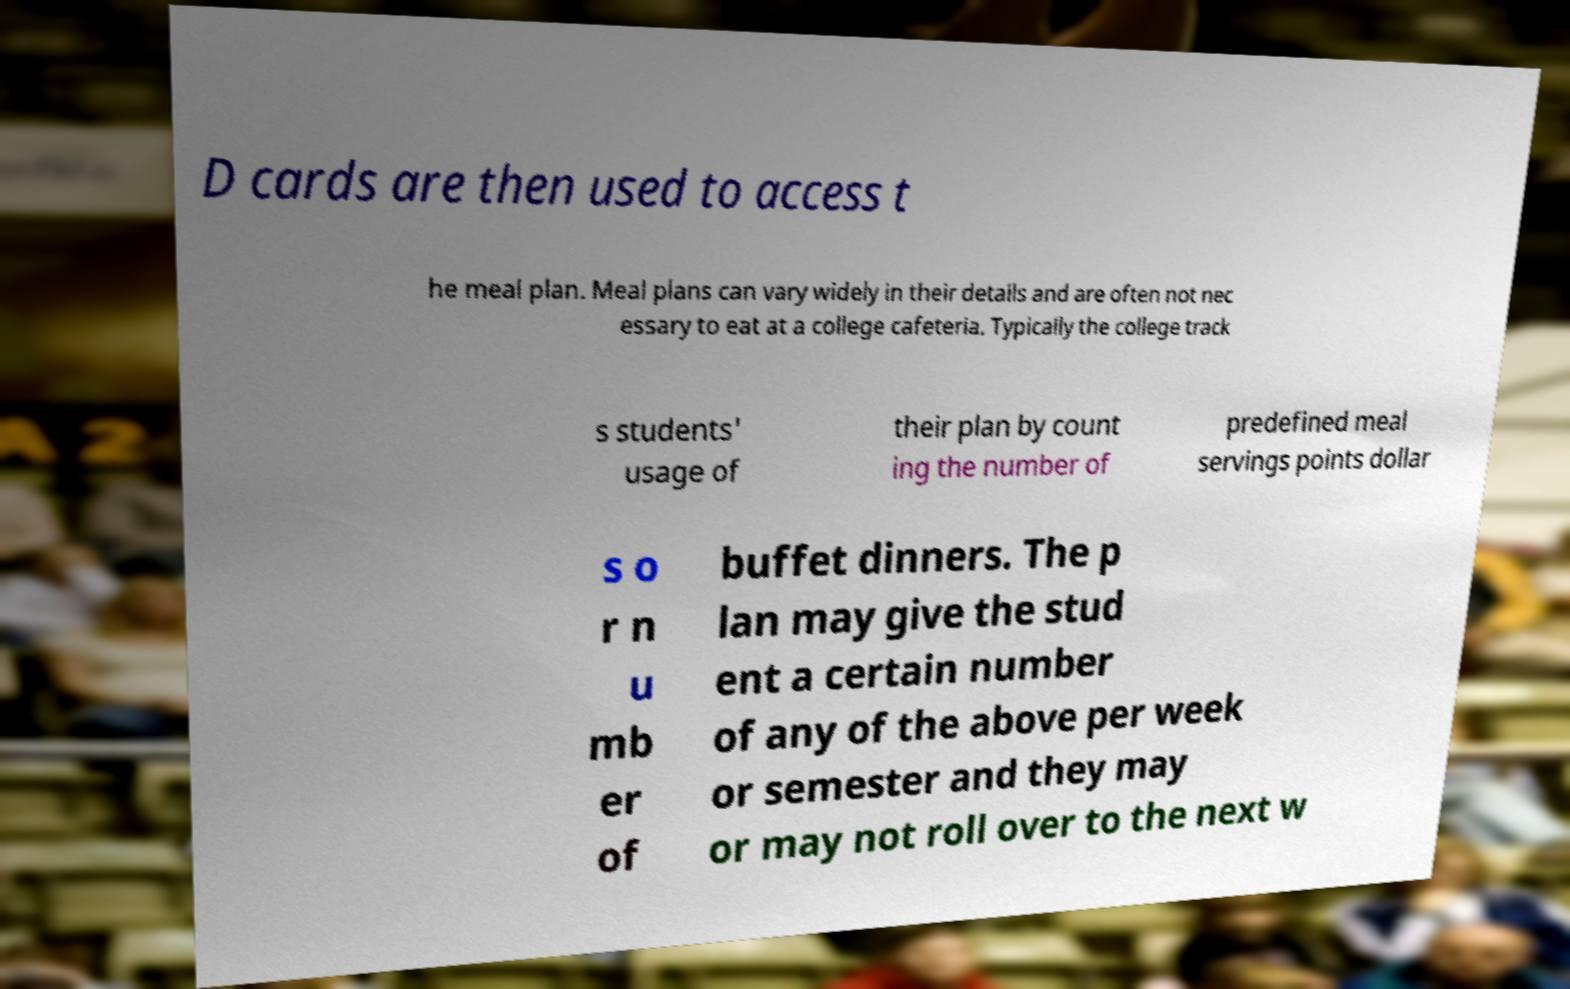There's text embedded in this image that I need extracted. Can you transcribe it verbatim? D cards are then used to access t he meal plan. Meal plans can vary widely in their details and are often not nec essary to eat at a college cafeteria. Typically the college track s students' usage of their plan by count ing the number of predefined meal servings points dollar s o r n u mb er of buffet dinners. The p lan may give the stud ent a certain number of any of the above per week or semester and they may or may not roll over to the next w 